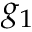Convert formula to latex. <formula><loc_0><loc_0><loc_500><loc_500>g _ { 1 }</formula> 